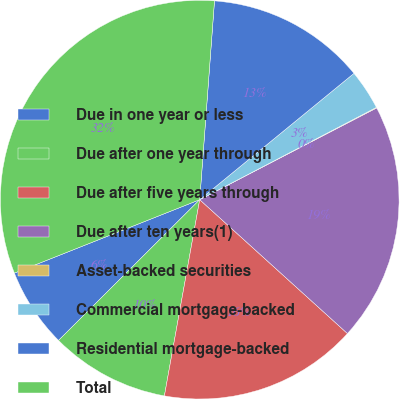Convert chart to OTSL. <chart><loc_0><loc_0><loc_500><loc_500><pie_chart><fcel>Due in one year or less<fcel>Due after one year through<fcel>Due after five years through<fcel>Due after ten years(1)<fcel>Asset-backed securities<fcel>Commercial mortgage-backed<fcel>Residential mortgage-backed<fcel>Total<nl><fcel>6.47%<fcel>9.69%<fcel>16.12%<fcel>19.33%<fcel>0.05%<fcel>3.26%<fcel>12.9%<fcel>32.19%<nl></chart> 